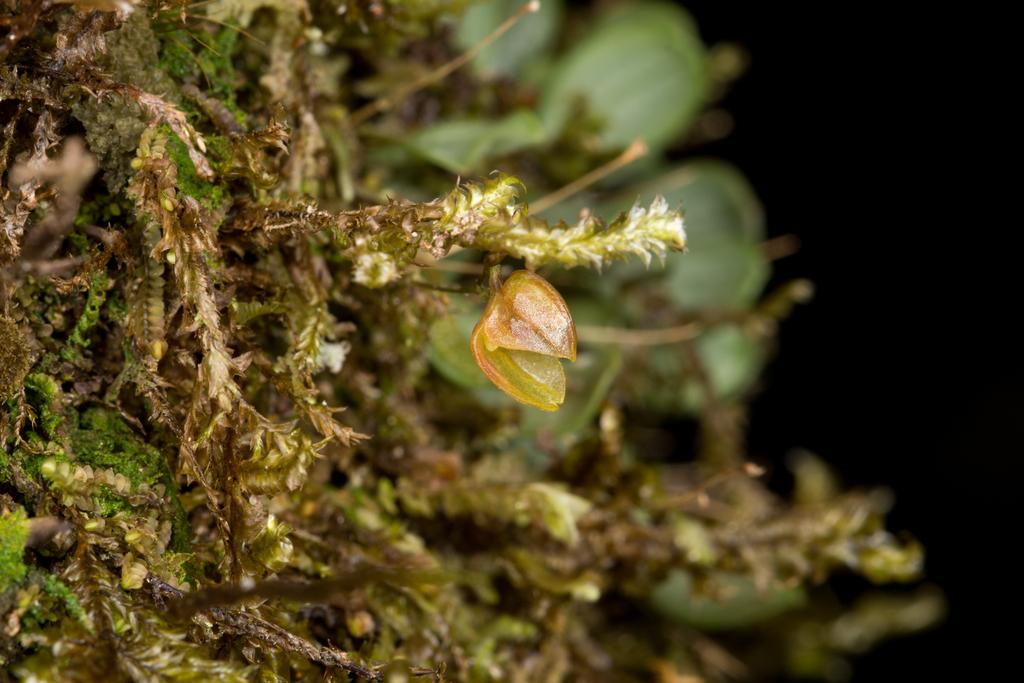What type of vegetation is visible in the image? There is grass and plants visible in the image. Can you describe the color of the image? The image has a dark color. Based on the color and the fact that there is grass and plants, what might be a possible time of day the image was taken? The image might have been taken during the night. What type of yam is being harvested by the carpenter in the image? There is no yam or carpenter present in the image. How many snakes can be seen slithering through the grass in the image? There are no snakes visible in the image. 